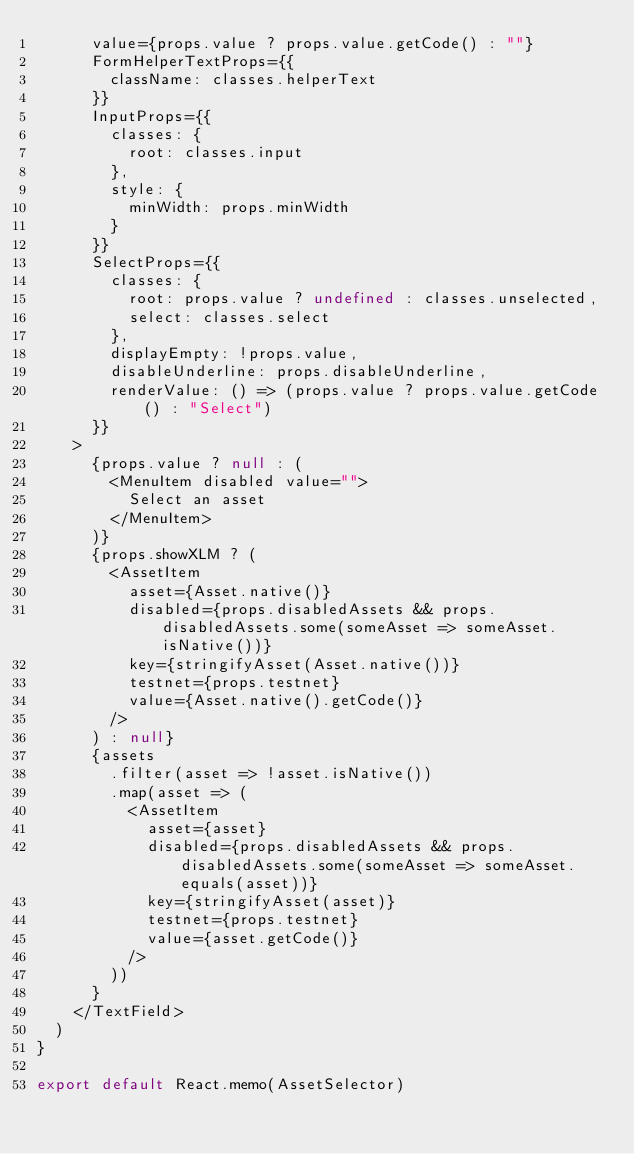<code> <loc_0><loc_0><loc_500><loc_500><_TypeScript_>      value={props.value ? props.value.getCode() : ""}
      FormHelperTextProps={{
        className: classes.helperText
      }}
      InputProps={{
        classes: {
          root: classes.input
        },
        style: {
          minWidth: props.minWidth
        }
      }}
      SelectProps={{
        classes: {
          root: props.value ? undefined : classes.unselected,
          select: classes.select
        },
        displayEmpty: !props.value,
        disableUnderline: props.disableUnderline,
        renderValue: () => (props.value ? props.value.getCode() : "Select")
      }}
    >
      {props.value ? null : (
        <MenuItem disabled value="">
          Select an asset
        </MenuItem>
      )}
      {props.showXLM ? (
        <AssetItem
          asset={Asset.native()}
          disabled={props.disabledAssets && props.disabledAssets.some(someAsset => someAsset.isNative())}
          key={stringifyAsset(Asset.native())}
          testnet={props.testnet}
          value={Asset.native().getCode()}
        />
      ) : null}
      {assets
        .filter(asset => !asset.isNative())
        .map(asset => (
          <AssetItem
            asset={asset}
            disabled={props.disabledAssets && props.disabledAssets.some(someAsset => someAsset.equals(asset))}
            key={stringifyAsset(asset)}
            testnet={props.testnet}
            value={asset.getCode()}
          />
        ))
      }
    </TextField>
  )
}

export default React.memo(AssetSelector)
</code> 